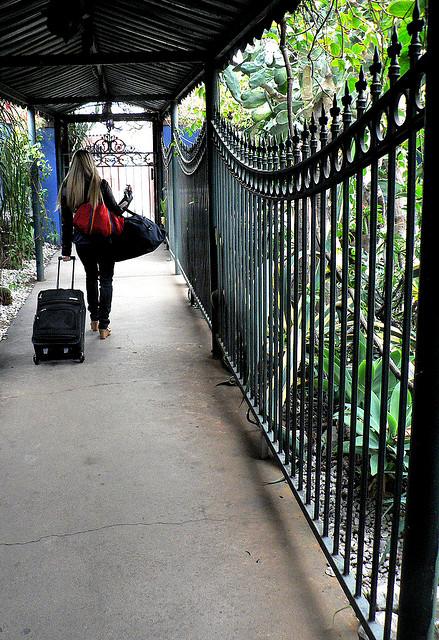What separates the sidewalk from the wildlife?
Concise answer only. Fence. What is the woman dragging?
Answer briefly. Suitcase. Is this woman running?
Be succinct. No. 